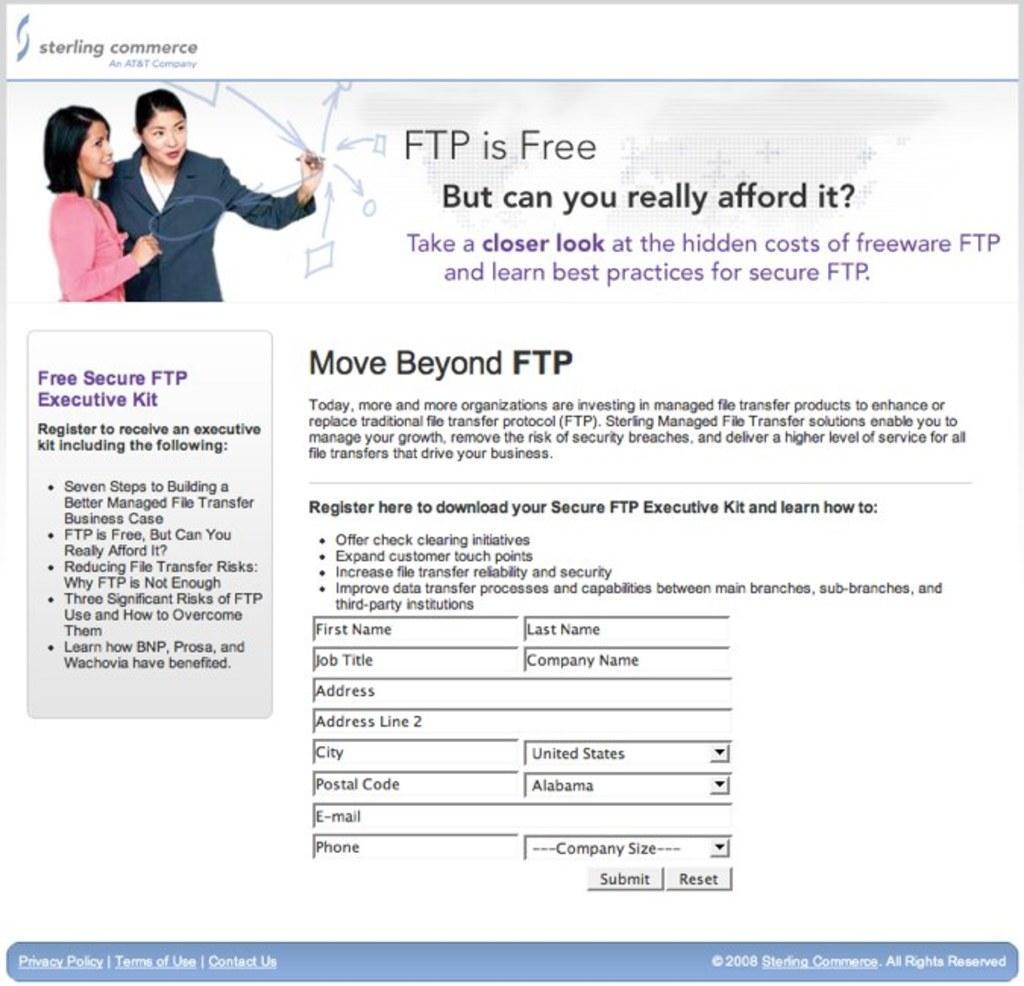Can you describe this image briefly? In this picture there are two women in the left top corner and there is something written beside and below it. 